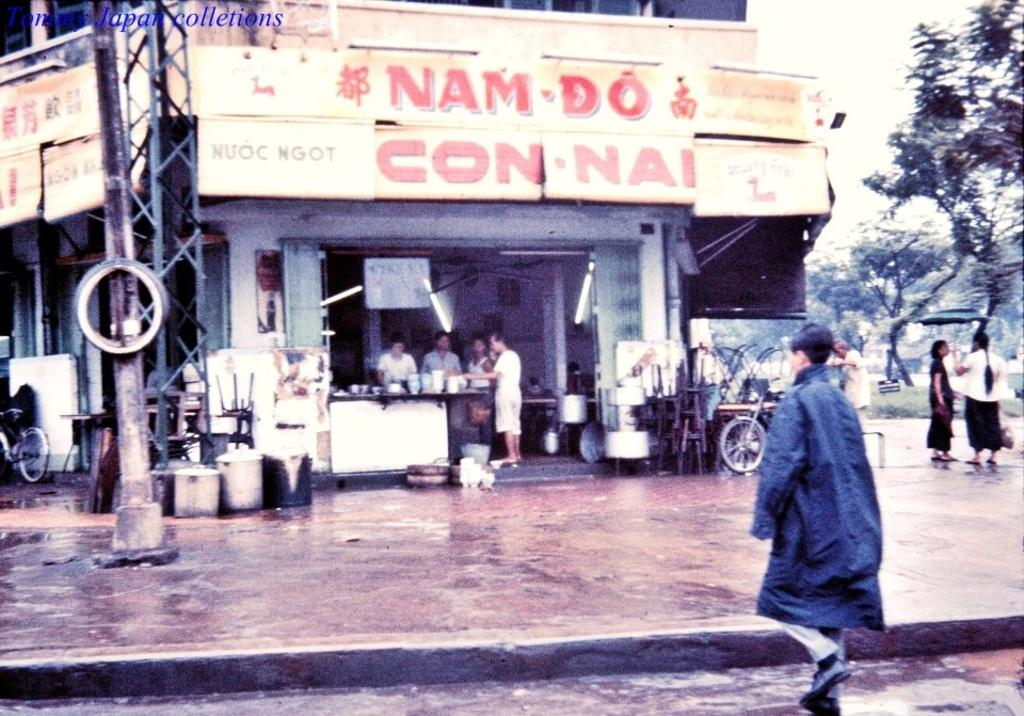What can be seen in the image? There are people standing in the image. What is visible in the background of the image? There are trees, buildings, poles, and bicycles in the background of the image. How many pizzas are being held by the pigs in the image? There are no pizzas or pigs present in the image. What is the source of the spark in the image? There is no spark present in the image. 